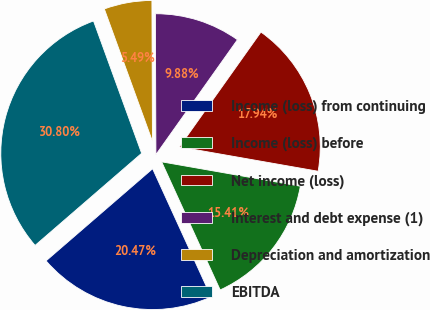<chart> <loc_0><loc_0><loc_500><loc_500><pie_chart><fcel>Income (loss) from continuing<fcel>Income (loss) before<fcel>Net income (loss)<fcel>Interest and debt expense (1)<fcel>Depreciation and amortization<fcel>EBITDA<nl><fcel>20.47%<fcel>15.41%<fcel>17.94%<fcel>9.88%<fcel>5.49%<fcel>30.79%<nl></chart> 